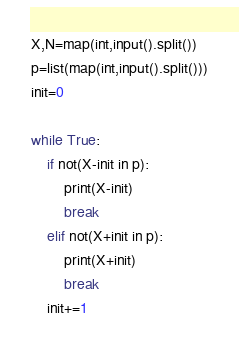Convert code to text. <code><loc_0><loc_0><loc_500><loc_500><_Python_>X,N=map(int,input().split())
p=list(map(int,input().split()))
init=0

while True:
    if not(X-init in p):
        print(X-init)
        break
    elif not(X+init in p):
        print(X+init)
        break
    init+=1</code> 